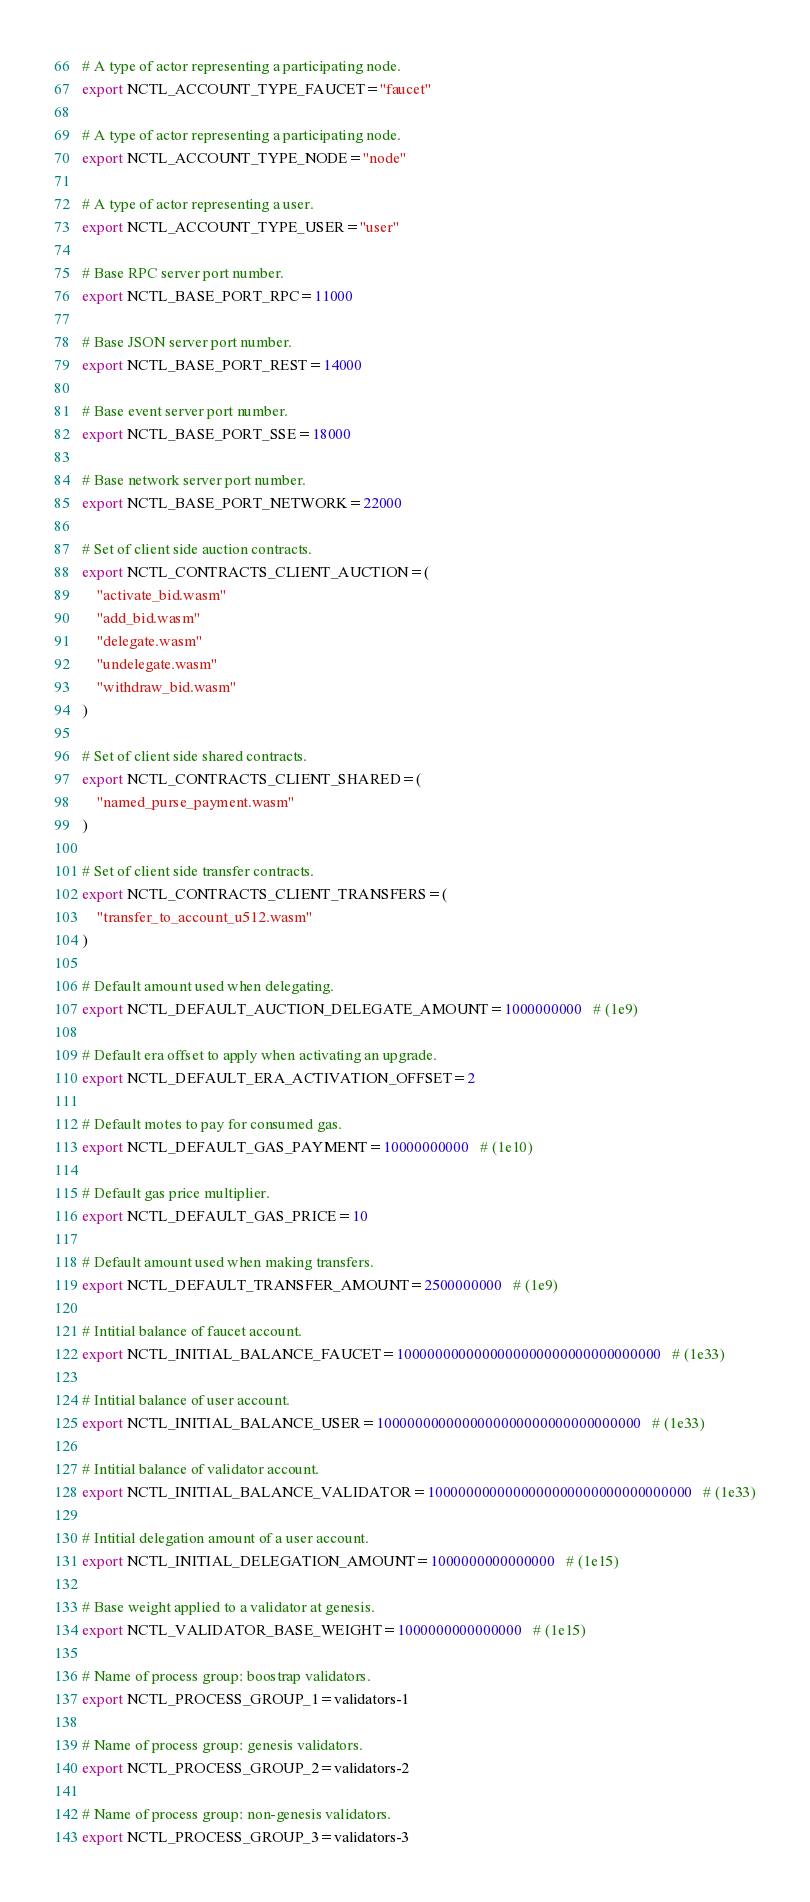<code> <loc_0><loc_0><loc_500><loc_500><_Bash_>
# A type of actor representing a participating node.
export NCTL_ACCOUNT_TYPE_FAUCET="faucet"

# A type of actor representing a participating node.
export NCTL_ACCOUNT_TYPE_NODE="node"

# A type of actor representing a user.
export NCTL_ACCOUNT_TYPE_USER="user"

# Base RPC server port number.
export NCTL_BASE_PORT_RPC=11000

# Base JSON server port number.
export NCTL_BASE_PORT_REST=14000

# Base event server port number.
export NCTL_BASE_PORT_SSE=18000

# Base network server port number.
export NCTL_BASE_PORT_NETWORK=22000

# Set of client side auction contracts.
export NCTL_CONTRACTS_CLIENT_AUCTION=(
    "activate_bid.wasm"
    "add_bid.wasm"
    "delegate.wasm"
    "undelegate.wasm"
    "withdraw_bid.wasm"
)

# Set of client side shared contracts.
export NCTL_CONTRACTS_CLIENT_SHARED=(
    "named_purse_payment.wasm"
)

# Set of client side transfer contracts.
export NCTL_CONTRACTS_CLIENT_TRANSFERS=(
    "transfer_to_account_u512.wasm"
)

# Default amount used when delegating.
export NCTL_DEFAULT_AUCTION_DELEGATE_AMOUNT=1000000000   # (1e9)

# Default era offset to apply when activating an upgrade.
export NCTL_DEFAULT_ERA_ACTIVATION_OFFSET=2

# Default motes to pay for consumed gas.
export NCTL_DEFAULT_GAS_PAYMENT=10000000000   # (1e10)

# Default gas price multiplier.
export NCTL_DEFAULT_GAS_PRICE=10

# Default amount used when making transfers.
export NCTL_DEFAULT_TRANSFER_AMOUNT=2500000000   # (1e9)

# Intitial balance of faucet account.
export NCTL_INITIAL_BALANCE_FAUCET=1000000000000000000000000000000000   # (1e33)

# Intitial balance of user account.
export NCTL_INITIAL_BALANCE_USER=1000000000000000000000000000000000   # (1e33)

# Intitial balance of validator account.
export NCTL_INITIAL_BALANCE_VALIDATOR=1000000000000000000000000000000000   # (1e33)

# Intitial delegation amount of a user account.
export NCTL_INITIAL_DELEGATION_AMOUNT=1000000000000000   # (1e15)

# Base weight applied to a validator at genesis.
export NCTL_VALIDATOR_BASE_WEIGHT=1000000000000000   # (1e15)

# Name of process group: boostrap validators.
export NCTL_PROCESS_GROUP_1=validators-1

# Name of process group: genesis validators.
export NCTL_PROCESS_GROUP_2=validators-2

# Name of process group: non-genesis validators.
export NCTL_PROCESS_GROUP_3=validators-3
</code> 